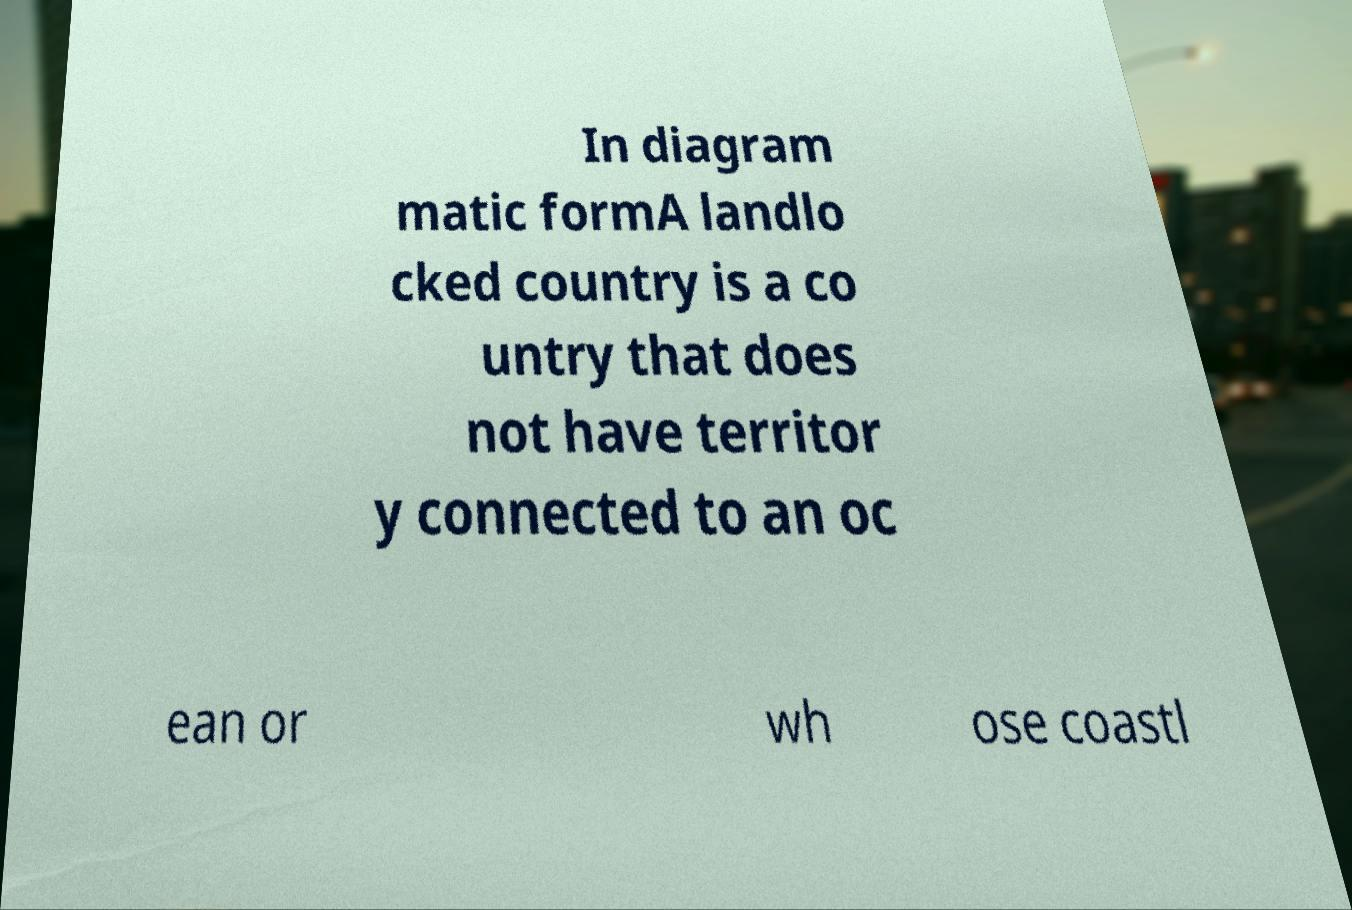Can you accurately transcribe the text from the provided image for me? In diagram matic formA landlo cked country is a co untry that does not have territor y connected to an oc ean or wh ose coastl 